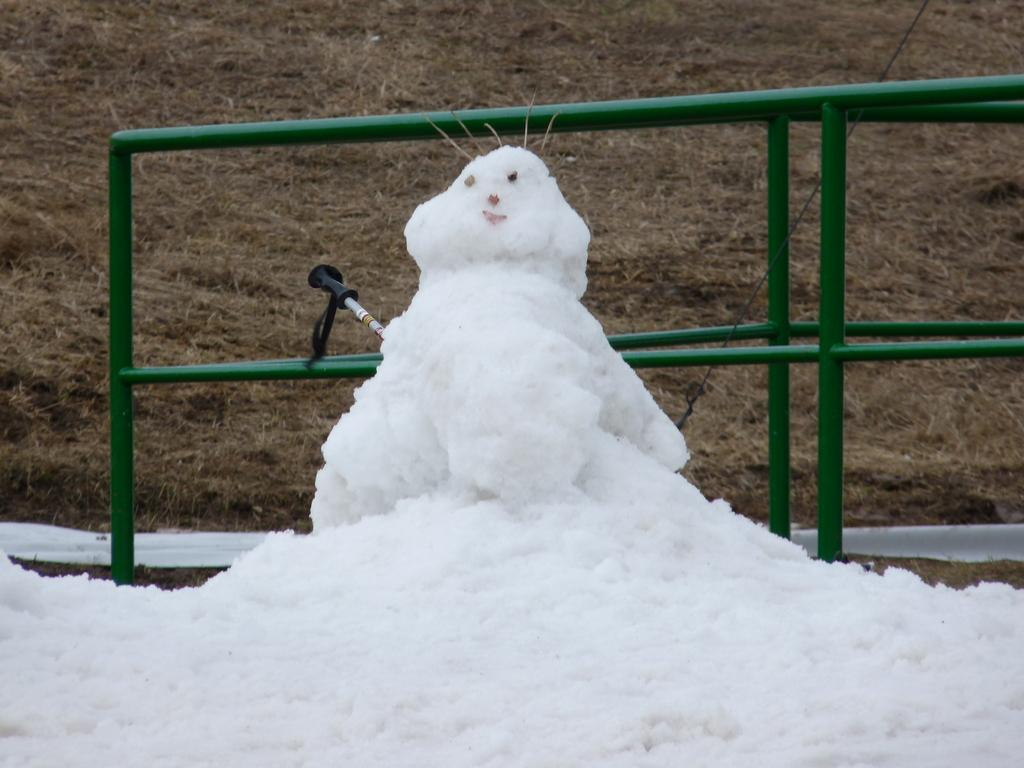What is the main feature in the center of the image? There is snow in the center of the image. What else can be seen in the image besides the snow? There is a toy in the image. What type of vegetation is visible in the background of the image? There is grass in the background of the image. What architectural feature is present in the background of the image? There is a fence in the background of the image. How does the snow improve the acoustics in the image? The snow does not improve the acoustics in the image; there is no mention of sound or acoustics in the provided facts. 